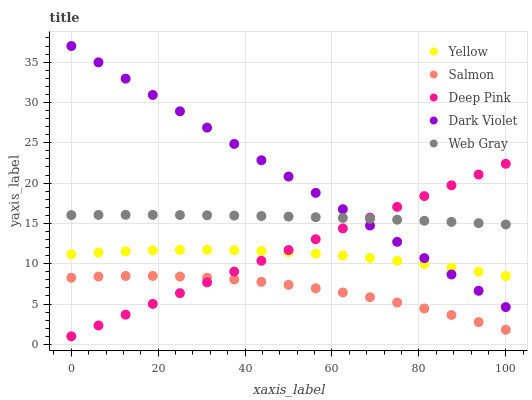Does Salmon have the minimum area under the curve?
Answer yes or no. Yes. Does Dark Violet have the maximum area under the curve?
Answer yes or no. Yes. Does Deep Pink have the minimum area under the curve?
Answer yes or no. No. Does Deep Pink have the maximum area under the curve?
Answer yes or no. No. Is Deep Pink the smoothest?
Answer yes or no. Yes. Is Salmon the roughest?
Answer yes or no. Yes. Is Salmon the smoothest?
Answer yes or no. No. Is Deep Pink the roughest?
Answer yes or no. No. Does Deep Pink have the lowest value?
Answer yes or no. Yes. Does Salmon have the lowest value?
Answer yes or no. No. Does Dark Violet have the highest value?
Answer yes or no. Yes. Does Deep Pink have the highest value?
Answer yes or no. No. Is Salmon less than Yellow?
Answer yes or no. Yes. Is Web Gray greater than Salmon?
Answer yes or no. Yes. Does Yellow intersect Dark Violet?
Answer yes or no. Yes. Is Yellow less than Dark Violet?
Answer yes or no. No. Is Yellow greater than Dark Violet?
Answer yes or no. No. Does Salmon intersect Yellow?
Answer yes or no. No. 